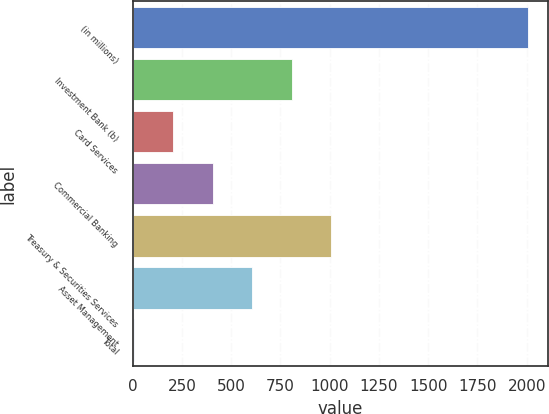<chart> <loc_0><loc_0><loc_500><loc_500><bar_chart><fcel>(in millions)<fcel>Investment Bank (b)<fcel>Card Services<fcel>Commercial Banking<fcel>Treasury & Securities Services<fcel>Asset Management<fcel>Total<nl><fcel>2009<fcel>807.2<fcel>206.3<fcel>406.6<fcel>1007.5<fcel>606.9<fcel>6<nl></chart> 